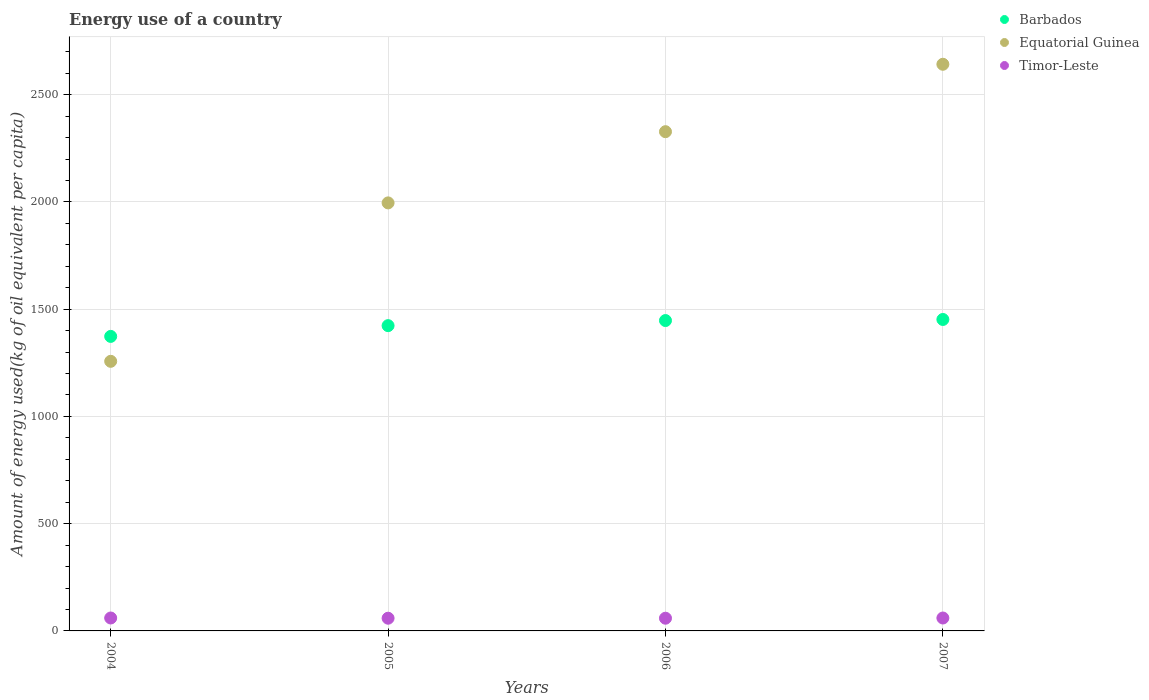Is the number of dotlines equal to the number of legend labels?
Offer a terse response. Yes. What is the amount of energy used in in Timor-Leste in 2006?
Your response must be concise. 59.23. Across all years, what is the maximum amount of energy used in in Equatorial Guinea?
Provide a succinct answer. 2641.94. Across all years, what is the minimum amount of energy used in in Timor-Leste?
Provide a short and direct response. 59.23. In which year was the amount of energy used in in Barbados maximum?
Your answer should be very brief. 2007. In which year was the amount of energy used in in Barbados minimum?
Make the answer very short. 2004. What is the total amount of energy used in in Barbados in the graph?
Make the answer very short. 5695.61. What is the difference between the amount of energy used in in Equatorial Guinea in 2004 and that in 2007?
Give a very brief answer. -1384.93. What is the difference between the amount of energy used in in Timor-Leste in 2006 and the amount of energy used in in Barbados in 2007?
Ensure brevity in your answer.  -1392.85. What is the average amount of energy used in in Equatorial Guinea per year?
Provide a succinct answer. 2055.56. In the year 2005, what is the difference between the amount of energy used in in Equatorial Guinea and amount of energy used in in Barbados?
Make the answer very short. 572.34. In how many years, is the amount of energy used in in Timor-Leste greater than 400 kg?
Offer a terse response. 0. What is the ratio of the amount of energy used in in Barbados in 2005 to that in 2007?
Your answer should be compact. 0.98. What is the difference between the highest and the second highest amount of energy used in in Timor-Leste?
Provide a short and direct response. 0.05. What is the difference between the highest and the lowest amount of energy used in in Barbados?
Provide a succinct answer. 78.92. Is the amount of energy used in in Barbados strictly greater than the amount of energy used in in Timor-Leste over the years?
Give a very brief answer. Yes. Is the amount of energy used in in Barbados strictly less than the amount of energy used in in Equatorial Guinea over the years?
Provide a succinct answer. No. How many dotlines are there?
Your answer should be compact. 3. What is the difference between two consecutive major ticks on the Y-axis?
Your answer should be compact. 500. Where does the legend appear in the graph?
Offer a very short reply. Top right. How many legend labels are there?
Your answer should be compact. 3. What is the title of the graph?
Offer a terse response. Energy use of a country. Does "Turkmenistan" appear as one of the legend labels in the graph?
Make the answer very short. No. What is the label or title of the X-axis?
Offer a terse response. Years. What is the label or title of the Y-axis?
Your response must be concise. Amount of energy used(kg of oil equivalent per capita). What is the Amount of energy used(kg of oil equivalent per capita) of Barbados in 2004?
Make the answer very short. 1373.17. What is the Amount of energy used(kg of oil equivalent per capita) of Equatorial Guinea in 2004?
Your response must be concise. 1257.01. What is the Amount of energy used(kg of oil equivalent per capita) in Timor-Leste in 2004?
Offer a terse response. 60.25. What is the Amount of energy used(kg of oil equivalent per capita) in Barbados in 2005?
Provide a short and direct response. 1423.29. What is the Amount of energy used(kg of oil equivalent per capita) in Equatorial Guinea in 2005?
Your answer should be compact. 1995.63. What is the Amount of energy used(kg of oil equivalent per capita) of Timor-Leste in 2005?
Give a very brief answer. 59.23. What is the Amount of energy used(kg of oil equivalent per capita) in Barbados in 2006?
Your response must be concise. 1447.06. What is the Amount of energy used(kg of oil equivalent per capita) in Equatorial Guinea in 2006?
Give a very brief answer. 2327.64. What is the Amount of energy used(kg of oil equivalent per capita) in Timor-Leste in 2006?
Your response must be concise. 59.23. What is the Amount of energy used(kg of oil equivalent per capita) in Barbados in 2007?
Make the answer very short. 1452.09. What is the Amount of energy used(kg of oil equivalent per capita) of Equatorial Guinea in 2007?
Give a very brief answer. 2641.94. What is the Amount of energy used(kg of oil equivalent per capita) in Timor-Leste in 2007?
Provide a succinct answer. 60.21. Across all years, what is the maximum Amount of energy used(kg of oil equivalent per capita) in Barbados?
Ensure brevity in your answer.  1452.09. Across all years, what is the maximum Amount of energy used(kg of oil equivalent per capita) of Equatorial Guinea?
Provide a succinct answer. 2641.94. Across all years, what is the maximum Amount of energy used(kg of oil equivalent per capita) of Timor-Leste?
Your answer should be very brief. 60.25. Across all years, what is the minimum Amount of energy used(kg of oil equivalent per capita) in Barbados?
Your answer should be compact. 1373.17. Across all years, what is the minimum Amount of energy used(kg of oil equivalent per capita) in Equatorial Guinea?
Offer a terse response. 1257.01. Across all years, what is the minimum Amount of energy used(kg of oil equivalent per capita) in Timor-Leste?
Offer a terse response. 59.23. What is the total Amount of energy used(kg of oil equivalent per capita) in Barbados in the graph?
Give a very brief answer. 5695.61. What is the total Amount of energy used(kg of oil equivalent per capita) of Equatorial Guinea in the graph?
Your answer should be compact. 8222.23. What is the total Amount of energy used(kg of oil equivalent per capita) in Timor-Leste in the graph?
Offer a very short reply. 238.92. What is the difference between the Amount of energy used(kg of oil equivalent per capita) in Barbados in 2004 and that in 2005?
Offer a terse response. -50.12. What is the difference between the Amount of energy used(kg of oil equivalent per capita) of Equatorial Guinea in 2004 and that in 2005?
Provide a succinct answer. -738.63. What is the difference between the Amount of energy used(kg of oil equivalent per capita) of Timor-Leste in 2004 and that in 2005?
Your answer should be very brief. 1.02. What is the difference between the Amount of energy used(kg of oil equivalent per capita) of Barbados in 2004 and that in 2006?
Offer a terse response. -73.89. What is the difference between the Amount of energy used(kg of oil equivalent per capita) of Equatorial Guinea in 2004 and that in 2006?
Your answer should be very brief. -1070.63. What is the difference between the Amount of energy used(kg of oil equivalent per capita) in Timor-Leste in 2004 and that in 2006?
Provide a short and direct response. 1.02. What is the difference between the Amount of energy used(kg of oil equivalent per capita) in Barbados in 2004 and that in 2007?
Offer a terse response. -78.92. What is the difference between the Amount of energy used(kg of oil equivalent per capita) of Equatorial Guinea in 2004 and that in 2007?
Make the answer very short. -1384.93. What is the difference between the Amount of energy used(kg of oil equivalent per capita) in Timor-Leste in 2004 and that in 2007?
Offer a very short reply. 0.05. What is the difference between the Amount of energy used(kg of oil equivalent per capita) of Barbados in 2005 and that in 2006?
Offer a terse response. -23.77. What is the difference between the Amount of energy used(kg of oil equivalent per capita) in Equatorial Guinea in 2005 and that in 2006?
Give a very brief answer. -332.01. What is the difference between the Amount of energy used(kg of oil equivalent per capita) in Timor-Leste in 2005 and that in 2006?
Give a very brief answer. -0. What is the difference between the Amount of energy used(kg of oil equivalent per capita) in Barbados in 2005 and that in 2007?
Offer a very short reply. -28.8. What is the difference between the Amount of energy used(kg of oil equivalent per capita) in Equatorial Guinea in 2005 and that in 2007?
Give a very brief answer. -646.31. What is the difference between the Amount of energy used(kg of oil equivalent per capita) in Timor-Leste in 2005 and that in 2007?
Your response must be concise. -0.97. What is the difference between the Amount of energy used(kg of oil equivalent per capita) in Barbados in 2006 and that in 2007?
Provide a short and direct response. -5.03. What is the difference between the Amount of energy used(kg of oil equivalent per capita) of Equatorial Guinea in 2006 and that in 2007?
Your response must be concise. -314.3. What is the difference between the Amount of energy used(kg of oil equivalent per capita) in Timor-Leste in 2006 and that in 2007?
Keep it short and to the point. -0.97. What is the difference between the Amount of energy used(kg of oil equivalent per capita) in Barbados in 2004 and the Amount of energy used(kg of oil equivalent per capita) in Equatorial Guinea in 2005?
Give a very brief answer. -622.47. What is the difference between the Amount of energy used(kg of oil equivalent per capita) in Barbados in 2004 and the Amount of energy used(kg of oil equivalent per capita) in Timor-Leste in 2005?
Provide a succinct answer. 1313.94. What is the difference between the Amount of energy used(kg of oil equivalent per capita) in Equatorial Guinea in 2004 and the Amount of energy used(kg of oil equivalent per capita) in Timor-Leste in 2005?
Your response must be concise. 1197.78. What is the difference between the Amount of energy used(kg of oil equivalent per capita) in Barbados in 2004 and the Amount of energy used(kg of oil equivalent per capita) in Equatorial Guinea in 2006?
Your answer should be compact. -954.47. What is the difference between the Amount of energy used(kg of oil equivalent per capita) of Barbados in 2004 and the Amount of energy used(kg of oil equivalent per capita) of Timor-Leste in 2006?
Your response must be concise. 1313.93. What is the difference between the Amount of energy used(kg of oil equivalent per capita) of Equatorial Guinea in 2004 and the Amount of energy used(kg of oil equivalent per capita) of Timor-Leste in 2006?
Ensure brevity in your answer.  1197.78. What is the difference between the Amount of energy used(kg of oil equivalent per capita) of Barbados in 2004 and the Amount of energy used(kg of oil equivalent per capita) of Equatorial Guinea in 2007?
Provide a succinct answer. -1268.77. What is the difference between the Amount of energy used(kg of oil equivalent per capita) in Barbados in 2004 and the Amount of energy used(kg of oil equivalent per capita) in Timor-Leste in 2007?
Offer a terse response. 1312.96. What is the difference between the Amount of energy used(kg of oil equivalent per capita) in Equatorial Guinea in 2004 and the Amount of energy used(kg of oil equivalent per capita) in Timor-Leste in 2007?
Keep it short and to the point. 1196.8. What is the difference between the Amount of energy used(kg of oil equivalent per capita) of Barbados in 2005 and the Amount of energy used(kg of oil equivalent per capita) of Equatorial Guinea in 2006?
Provide a short and direct response. -904.35. What is the difference between the Amount of energy used(kg of oil equivalent per capita) of Barbados in 2005 and the Amount of energy used(kg of oil equivalent per capita) of Timor-Leste in 2006?
Your response must be concise. 1364.06. What is the difference between the Amount of energy used(kg of oil equivalent per capita) of Equatorial Guinea in 2005 and the Amount of energy used(kg of oil equivalent per capita) of Timor-Leste in 2006?
Your answer should be very brief. 1936.4. What is the difference between the Amount of energy used(kg of oil equivalent per capita) of Barbados in 2005 and the Amount of energy used(kg of oil equivalent per capita) of Equatorial Guinea in 2007?
Keep it short and to the point. -1218.65. What is the difference between the Amount of energy used(kg of oil equivalent per capita) of Barbados in 2005 and the Amount of energy used(kg of oil equivalent per capita) of Timor-Leste in 2007?
Ensure brevity in your answer.  1363.08. What is the difference between the Amount of energy used(kg of oil equivalent per capita) of Equatorial Guinea in 2005 and the Amount of energy used(kg of oil equivalent per capita) of Timor-Leste in 2007?
Provide a succinct answer. 1935.43. What is the difference between the Amount of energy used(kg of oil equivalent per capita) of Barbados in 2006 and the Amount of energy used(kg of oil equivalent per capita) of Equatorial Guinea in 2007?
Give a very brief answer. -1194.88. What is the difference between the Amount of energy used(kg of oil equivalent per capita) in Barbados in 2006 and the Amount of energy used(kg of oil equivalent per capita) in Timor-Leste in 2007?
Your answer should be compact. 1386.86. What is the difference between the Amount of energy used(kg of oil equivalent per capita) in Equatorial Guinea in 2006 and the Amount of energy used(kg of oil equivalent per capita) in Timor-Leste in 2007?
Provide a short and direct response. 2267.44. What is the average Amount of energy used(kg of oil equivalent per capita) in Barbados per year?
Give a very brief answer. 1423.9. What is the average Amount of energy used(kg of oil equivalent per capita) in Equatorial Guinea per year?
Ensure brevity in your answer.  2055.56. What is the average Amount of energy used(kg of oil equivalent per capita) of Timor-Leste per year?
Make the answer very short. 59.73. In the year 2004, what is the difference between the Amount of energy used(kg of oil equivalent per capita) in Barbados and Amount of energy used(kg of oil equivalent per capita) in Equatorial Guinea?
Keep it short and to the point. 116.16. In the year 2004, what is the difference between the Amount of energy used(kg of oil equivalent per capita) of Barbados and Amount of energy used(kg of oil equivalent per capita) of Timor-Leste?
Your response must be concise. 1312.92. In the year 2004, what is the difference between the Amount of energy used(kg of oil equivalent per capita) in Equatorial Guinea and Amount of energy used(kg of oil equivalent per capita) in Timor-Leste?
Offer a very short reply. 1196.76. In the year 2005, what is the difference between the Amount of energy used(kg of oil equivalent per capita) in Barbados and Amount of energy used(kg of oil equivalent per capita) in Equatorial Guinea?
Ensure brevity in your answer.  -572.34. In the year 2005, what is the difference between the Amount of energy used(kg of oil equivalent per capita) in Barbados and Amount of energy used(kg of oil equivalent per capita) in Timor-Leste?
Your answer should be compact. 1364.06. In the year 2005, what is the difference between the Amount of energy used(kg of oil equivalent per capita) in Equatorial Guinea and Amount of energy used(kg of oil equivalent per capita) in Timor-Leste?
Your answer should be compact. 1936.4. In the year 2006, what is the difference between the Amount of energy used(kg of oil equivalent per capita) of Barbados and Amount of energy used(kg of oil equivalent per capita) of Equatorial Guinea?
Offer a terse response. -880.58. In the year 2006, what is the difference between the Amount of energy used(kg of oil equivalent per capita) in Barbados and Amount of energy used(kg of oil equivalent per capita) in Timor-Leste?
Make the answer very short. 1387.83. In the year 2006, what is the difference between the Amount of energy used(kg of oil equivalent per capita) of Equatorial Guinea and Amount of energy used(kg of oil equivalent per capita) of Timor-Leste?
Provide a short and direct response. 2268.41. In the year 2007, what is the difference between the Amount of energy used(kg of oil equivalent per capita) of Barbados and Amount of energy used(kg of oil equivalent per capita) of Equatorial Guinea?
Ensure brevity in your answer.  -1189.85. In the year 2007, what is the difference between the Amount of energy used(kg of oil equivalent per capita) of Barbados and Amount of energy used(kg of oil equivalent per capita) of Timor-Leste?
Provide a succinct answer. 1391.88. In the year 2007, what is the difference between the Amount of energy used(kg of oil equivalent per capita) of Equatorial Guinea and Amount of energy used(kg of oil equivalent per capita) of Timor-Leste?
Keep it short and to the point. 2581.74. What is the ratio of the Amount of energy used(kg of oil equivalent per capita) in Barbados in 2004 to that in 2005?
Provide a short and direct response. 0.96. What is the ratio of the Amount of energy used(kg of oil equivalent per capita) of Equatorial Guinea in 2004 to that in 2005?
Offer a terse response. 0.63. What is the ratio of the Amount of energy used(kg of oil equivalent per capita) in Timor-Leste in 2004 to that in 2005?
Ensure brevity in your answer.  1.02. What is the ratio of the Amount of energy used(kg of oil equivalent per capita) of Barbados in 2004 to that in 2006?
Give a very brief answer. 0.95. What is the ratio of the Amount of energy used(kg of oil equivalent per capita) of Equatorial Guinea in 2004 to that in 2006?
Your answer should be very brief. 0.54. What is the ratio of the Amount of energy used(kg of oil equivalent per capita) of Timor-Leste in 2004 to that in 2006?
Provide a short and direct response. 1.02. What is the ratio of the Amount of energy used(kg of oil equivalent per capita) in Barbados in 2004 to that in 2007?
Give a very brief answer. 0.95. What is the ratio of the Amount of energy used(kg of oil equivalent per capita) of Equatorial Guinea in 2004 to that in 2007?
Provide a succinct answer. 0.48. What is the ratio of the Amount of energy used(kg of oil equivalent per capita) in Timor-Leste in 2004 to that in 2007?
Provide a short and direct response. 1. What is the ratio of the Amount of energy used(kg of oil equivalent per capita) in Barbados in 2005 to that in 2006?
Your answer should be compact. 0.98. What is the ratio of the Amount of energy used(kg of oil equivalent per capita) of Equatorial Guinea in 2005 to that in 2006?
Your answer should be very brief. 0.86. What is the ratio of the Amount of energy used(kg of oil equivalent per capita) in Barbados in 2005 to that in 2007?
Provide a short and direct response. 0.98. What is the ratio of the Amount of energy used(kg of oil equivalent per capita) in Equatorial Guinea in 2005 to that in 2007?
Make the answer very short. 0.76. What is the ratio of the Amount of energy used(kg of oil equivalent per capita) in Timor-Leste in 2005 to that in 2007?
Give a very brief answer. 0.98. What is the ratio of the Amount of energy used(kg of oil equivalent per capita) in Barbados in 2006 to that in 2007?
Offer a very short reply. 1. What is the ratio of the Amount of energy used(kg of oil equivalent per capita) of Equatorial Guinea in 2006 to that in 2007?
Offer a terse response. 0.88. What is the ratio of the Amount of energy used(kg of oil equivalent per capita) of Timor-Leste in 2006 to that in 2007?
Provide a succinct answer. 0.98. What is the difference between the highest and the second highest Amount of energy used(kg of oil equivalent per capita) in Barbados?
Provide a short and direct response. 5.03. What is the difference between the highest and the second highest Amount of energy used(kg of oil equivalent per capita) in Equatorial Guinea?
Provide a short and direct response. 314.3. What is the difference between the highest and the second highest Amount of energy used(kg of oil equivalent per capita) of Timor-Leste?
Offer a terse response. 0.05. What is the difference between the highest and the lowest Amount of energy used(kg of oil equivalent per capita) of Barbados?
Offer a terse response. 78.92. What is the difference between the highest and the lowest Amount of energy used(kg of oil equivalent per capita) in Equatorial Guinea?
Offer a very short reply. 1384.93. What is the difference between the highest and the lowest Amount of energy used(kg of oil equivalent per capita) of Timor-Leste?
Offer a terse response. 1.02. 